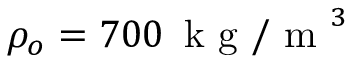<formula> <loc_0><loc_0><loc_500><loc_500>\rho _ { o } = 7 0 0 \, k g / m ^ { 3 }</formula> 